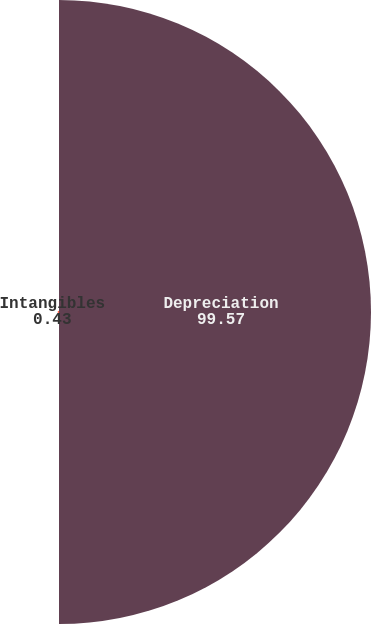Convert chart to OTSL. <chart><loc_0><loc_0><loc_500><loc_500><pie_chart><fcel>Depreciation<fcel>Intangibles<nl><fcel>99.57%<fcel>0.43%<nl></chart> 